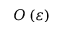Convert formula to latex. <formula><loc_0><loc_0><loc_500><loc_500>O \left ( \varepsilon \right )</formula> 